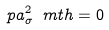<formula> <loc_0><loc_0><loc_500><loc_500>\ p a _ { \sigma } ^ { 2 } \ m t h = 0</formula> 